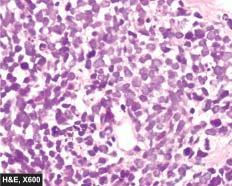how are the individual tumour cells?
Answer the question using a single word or phrase. Small 